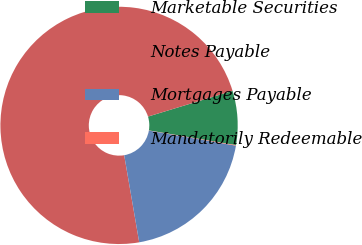Convert chart to OTSL. <chart><loc_0><loc_0><loc_500><loc_500><pie_chart><fcel>Marketable Securities<fcel>Notes Payable<fcel>Mortgages Payable<fcel>Mandatorily Redeemable<nl><fcel>7.37%<fcel>73.01%<fcel>19.55%<fcel>0.07%<nl></chart> 